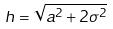<formula> <loc_0><loc_0><loc_500><loc_500>h = \sqrt { a ^ { 2 } + 2 \sigma ^ { 2 } }</formula> 